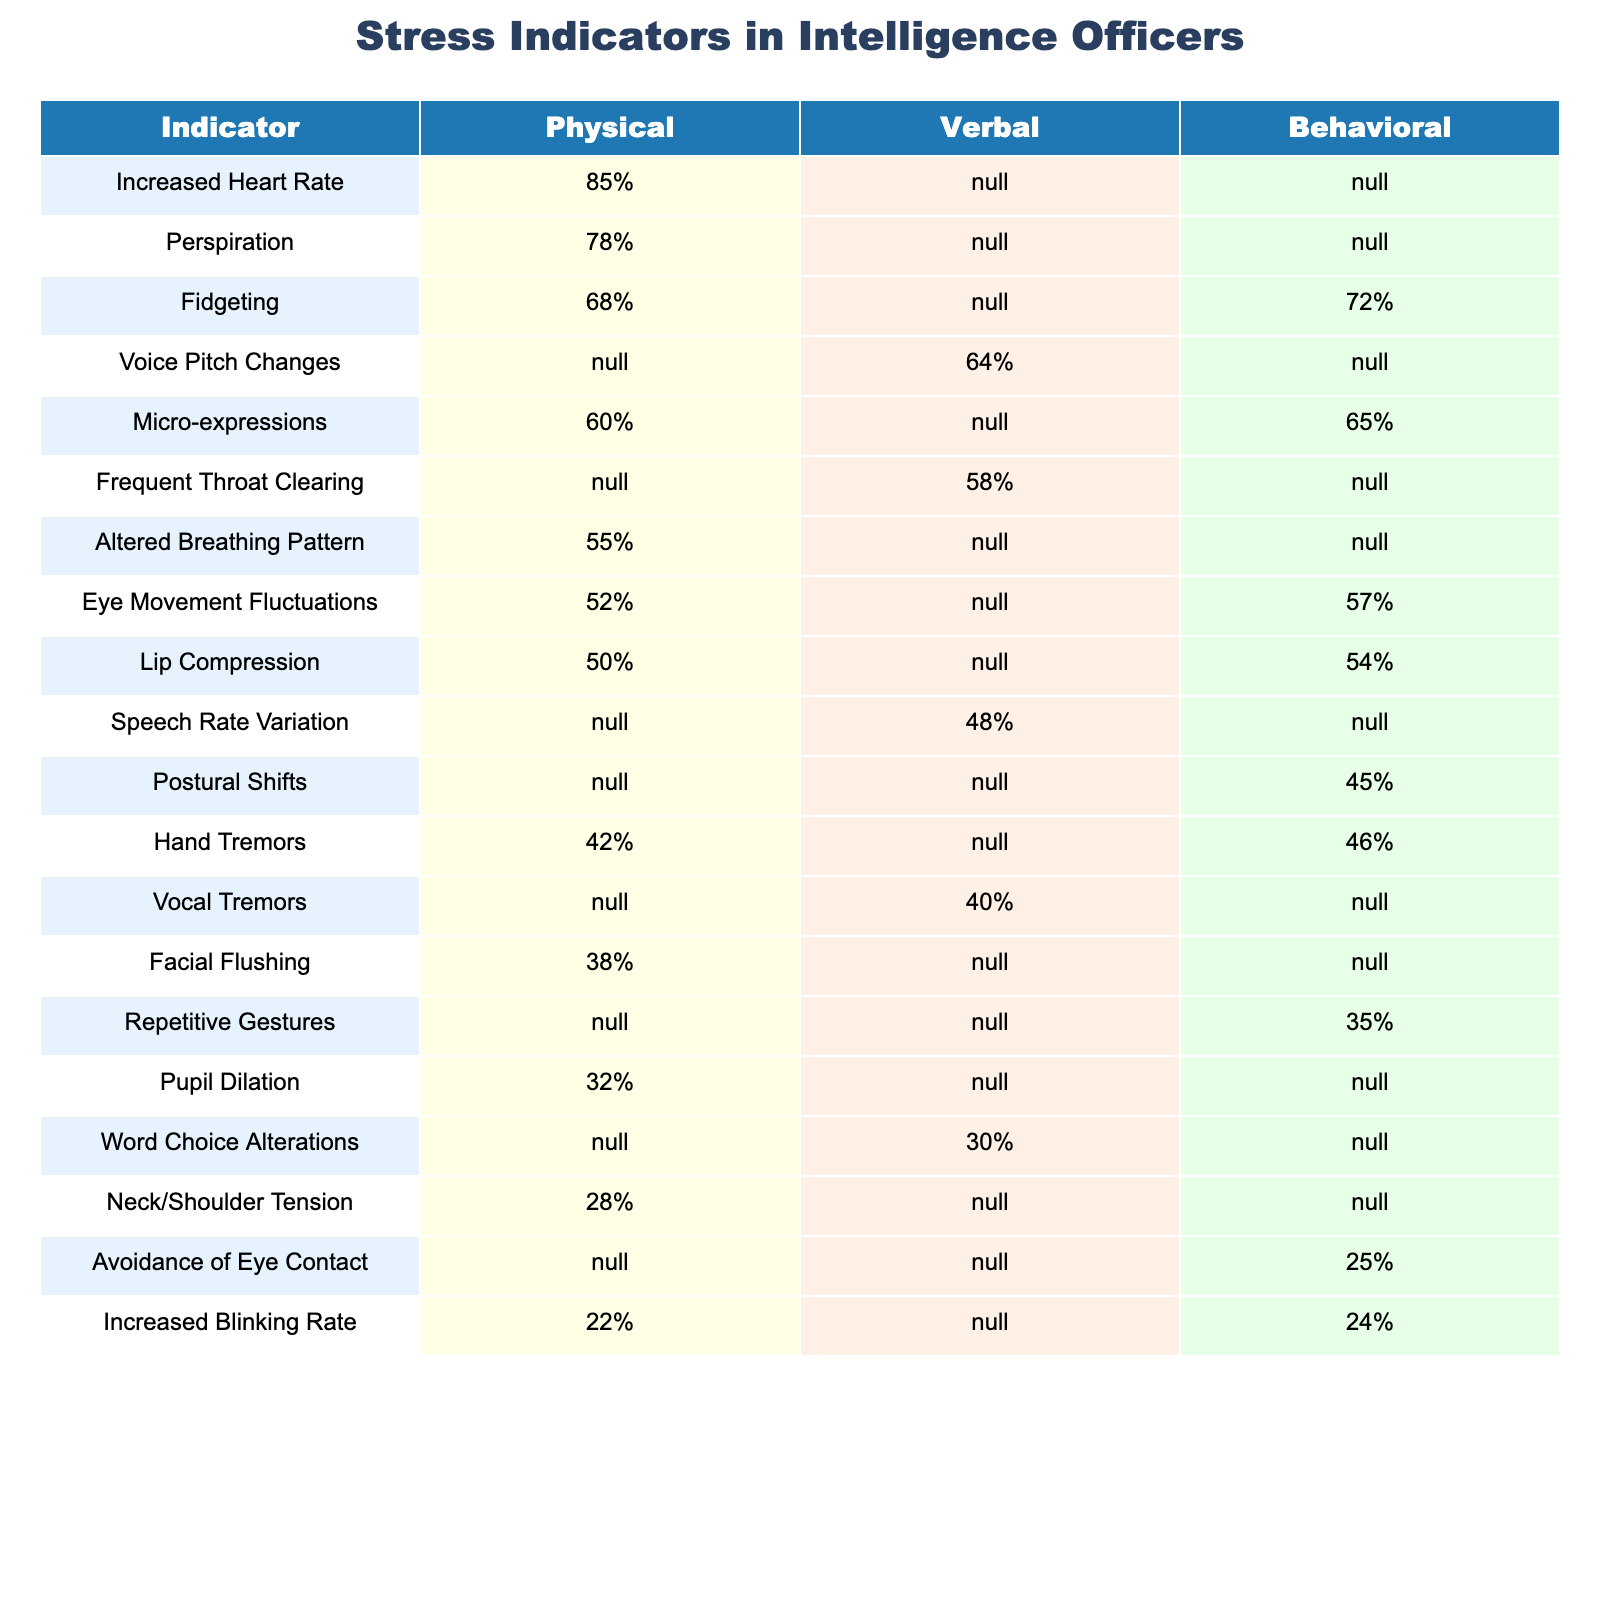What is the stress indicator with the highest observed physical manifestation? The table shows that "Increased Heart Rate" has the highest physical manifestation at 85%.
Answer: Increased Heart Rate Which behavioral indicator has the highest percentage? The highest percentage for a behavioral indicator is "Fidgeting" at 68%.
Answer: Fidgeting Is there a verbal indicator with a percentage greater than 70%? The table indicates that there are no verbal indicators with a percentage greater than 70%; the highest is "Voice Pitch Changes" at 64%.
Answer: No What is the difference in percentage between the physical and behavioral manifestation of "Lip Compression"? "Lip Compression" has a physical percentage of 50% and a behavioral percentage of 54%. The difference is 54% - 50% = 4%.
Answer: 4% What percentage of intelligence officers exhibit "Pupil Dilation"? The table states that "Pupil Dilation" is observed in 32% of intelligence officers.
Answer: 32% Which indicator shows a greater impact, "Facial Flushing" or "Increased Blinking Rate"? "Facial Flushing" is at 38% and "Increased Blinking Rate" is at 22%; clearly, 38% is greater than 22%.
Answer: Facial Flushing What is the average percentage of all the physical indicators listed? The physical indicators listed are "Increased Heart Rate" (85%), "Perspiration" (78%), "Altered Breathing Pattern" (55%), "Eye Movement Fluctuations" (52%), "Lip Compression" (50%), "Hand Tremors" (42%), "Facial Flushing" (38%), and "Pupil Dilation" (32%). The average percentage is (85 + 78 + 55 + 52 + 50 + 42 + 38 + 32) / 8 = 52.5%.
Answer: 52.5% How many indicators show a behavioral manifestation percentage below 40%? The indicators with a behavioral manifestation percentage below 40% are "Avoidance of Eye Contact" (25%), "Repetitive Gestures" (35%), and "Increased Blinking Rate" (24%). That totals 3 indicators.
Answer: 3 What is the total number of indicators listed in the table? There are 14 unique indicators listed in the table.
Answer: 14 